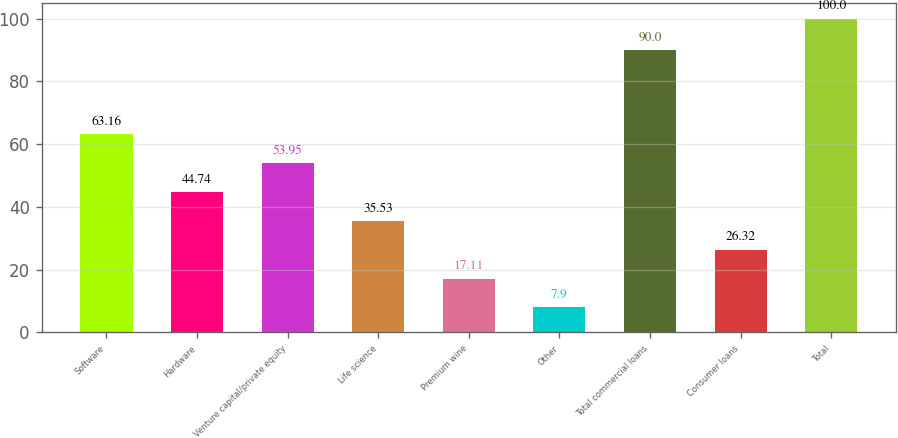<chart> <loc_0><loc_0><loc_500><loc_500><bar_chart><fcel>Software<fcel>Hardware<fcel>Venture capital/private equity<fcel>Life science<fcel>Premium wine<fcel>Other<fcel>Total commercial loans<fcel>Consumer loans<fcel>Total<nl><fcel>63.16<fcel>44.74<fcel>53.95<fcel>35.53<fcel>17.11<fcel>7.9<fcel>90<fcel>26.32<fcel>100<nl></chart> 